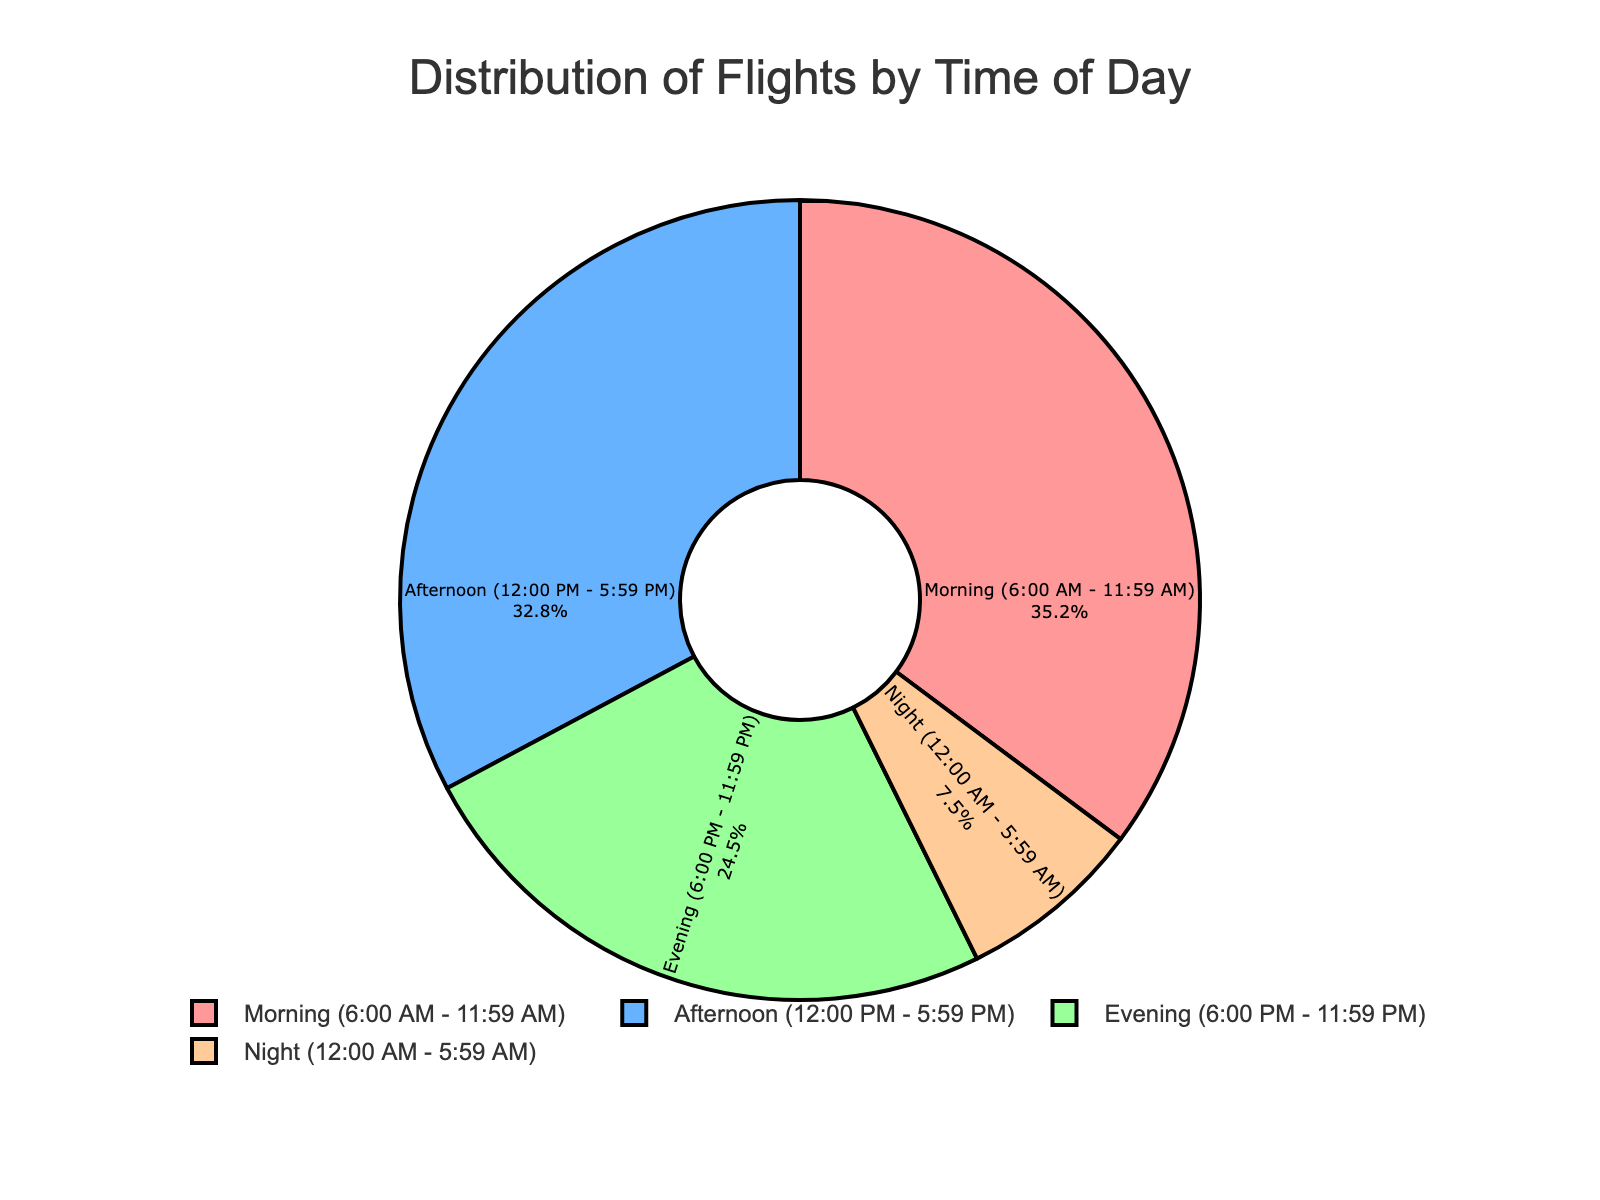What time of day has the highest percentage of flights? The figure shows four categories: Morning, Afternoon, Evening, and Night. By comparing the percentages, Morning has the highest percentage at 35.2%
Answer: Morning Which time of day has the lowest percentage of flights? The figure shows four categories: Morning, Afternoon, Evening, and Night. By comparing the percentages, Night has the lowest percentage at 7.5%
Answer: Night How many percentage points more flights are there in the Morning compared to the Night? The percentage of flights in the Morning is 35.2%. The percentage of flights at Night is 7.5%. The difference is 35.2% - 7.5% = 27.7%.
Answer: 27.7% What is the combined percentage of flights in the Afternoon and Evening? The percentage of flights in the Afternoon is 32.8%, and in the Evening, it is 24.5%. The sum is 32.8% + 24.5% = 57.3%.
Answer: 57.3% Which two time periods combined make up more than half of the flights, and what is their combined percentage? The Morning and Afternoon periods combined are 35.2% + 32.8% = 68%. This is more than half (50%) of the flights.
Answer: Morning and Afternoon, 68% Are there more flights in the Afternoon or in the Evening, and by how many percentage points? The percentage of flights in the Afternoon is 32.8%, and in the Evening, it is 24.5%. The Afternoon has 32.8% - 24.5% = 8.3% more flights.
Answer: Afternoon, 8.3% What is the percentage difference between flights in the Morning and in the Afternoon? The percentage of flights in the Morning is 35.2%, and in the Afternoon, it is 32.8%. The difference is 35.2% - 32.8% = 2.4%.
Answer: 2.4% What time of day is responsible for the second highest number of flights? The figure shows Morning, Afternoon, Evening, and Night. The time with the second highest percentage of flights is Afternoon at 32.8%.
Answer: Afternoon How does the percentage of flights in the Evening compare to the percentage of flights at Night? The Evening has 24.5% of flights, while the Night has 7.5%. The Evening has a higher percentage of flights by 24.5% - 7.5% = 17%.
Answer: Evening, 17% What is the percentage of flights occurring outside of nighttime (12:00 AM - 5:59 AM)? The nighttime percentage is 7.5%. The percentage outside of nighttime is 100% - 7.5% = 92.5%.
Answer: 92.5% 